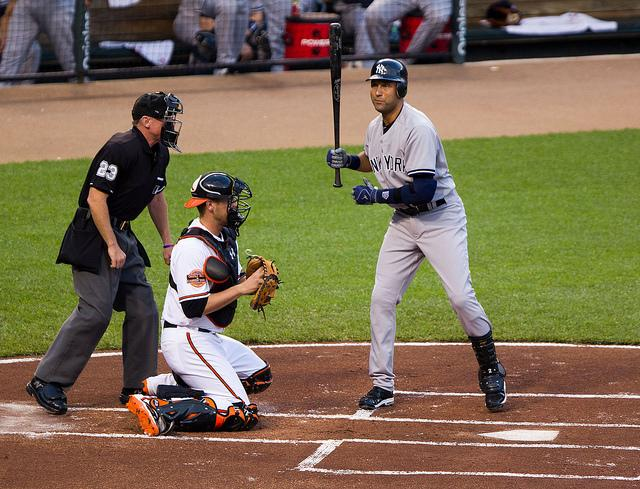Who is the man up to bat? Please explain your reasoning. derek jeter. The man is wearing a new york uniform and derek jeter plays for new york. 